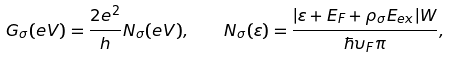<formula> <loc_0><loc_0><loc_500><loc_500>G _ { \sigma } ( e V ) = \frac { 2 e ^ { 2 } } { h } N _ { \sigma } ( e V ) , \quad N _ { \sigma } ( \varepsilon ) = \frac { | \varepsilon + E _ { F } + \rho _ { \sigma } E _ { e x } | W } { \hbar { \upsilon } _ { F } \pi } ,</formula> 